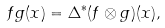Convert formula to latex. <formula><loc_0><loc_0><loc_500><loc_500>f g ( x ) = \Delta ^ { * } ( f \otimes g ) ( x ) ,</formula> 